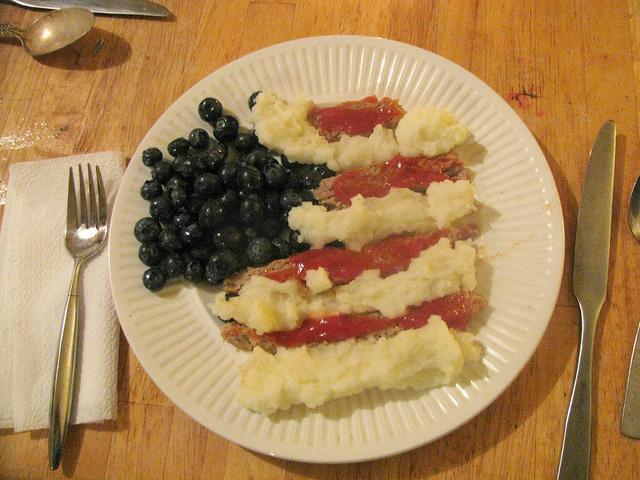How many utensils can be seen?
Give a very brief answer. 5. How many spoons are in the picture?
Give a very brief answer. 1. 